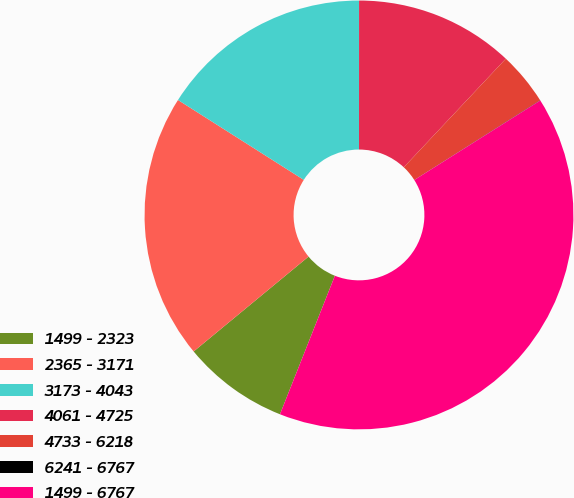<chart> <loc_0><loc_0><loc_500><loc_500><pie_chart><fcel>1499 - 2323<fcel>2365 - 3171<fcel>3173 - 4043<fcel>4061 - 4725<fcel>4733 - 6218<fcel>6241 - 6767<fcel>1499 - 6767<nl><fcel>8.01%<fcel>19.99%<fcel>16.0%<fcel>12.0%<fcel>4.01%<fcel>0.02%<fcel>39.97%<nl></chart> 